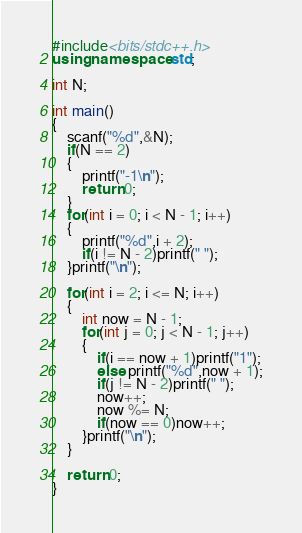<code> <loc_0><loc_0><loc_500><loc_500><_C++_>#include<bits/stdc++.h>
using namespace std;

int N;

int main()
{
    scanf("%d",&N);
    if(N == 2)
    {
        printf("-1\n");
        return 0;
    }
    for(int i = 0; i < N - 1; i++)
    {
        printf("%d",i + 2);
        if(i != N - 2)printf(" ");
    }printf("\n");

    for(int i = 2; i <= N; i++)
    {
        int now = N - 1;
        for(int j = 0; j < N - 1; j++)
        {
            if(i == now + 1)printf("1");
            else printf("%d",now + 1);
            if(j != N - 2)printf(" ");
            now++;
            now %= N;
            if(now == 0)now++;
        }printf("\n");
    }

    return 0;
}
</code> 